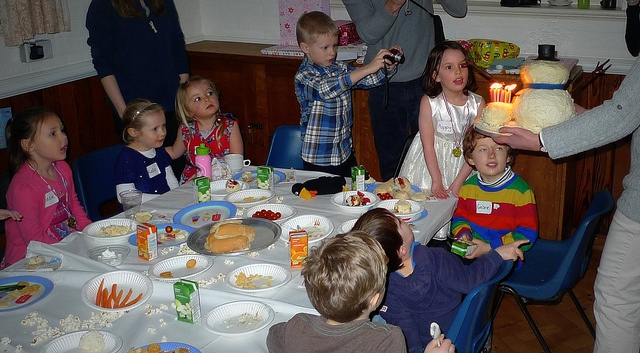Describe the objects in this image and their specific colors. I can see dining table in gray, darkgray, lightgray, and tan tones, people in gray and brown tones, people in gray, black, and maroon tones, people in gray, navy, and black tones, and people in gray, black, and maroon tones in this image. 